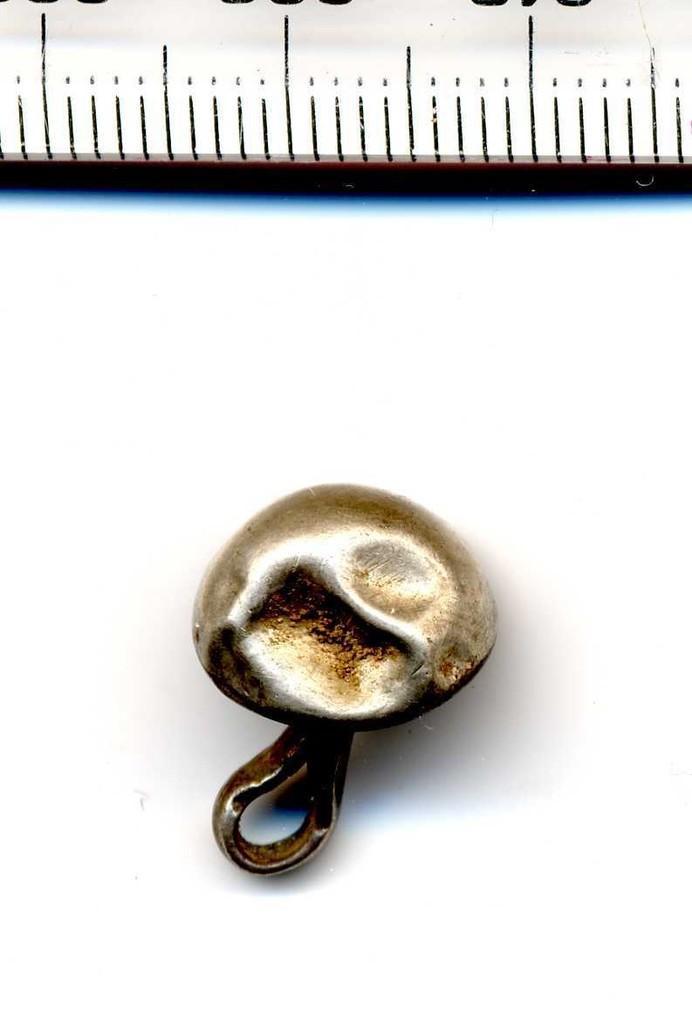Describe this image in one or two sentences. In the center of the image we can see an object is present on the surface. At the top of the image we can see the scale. 